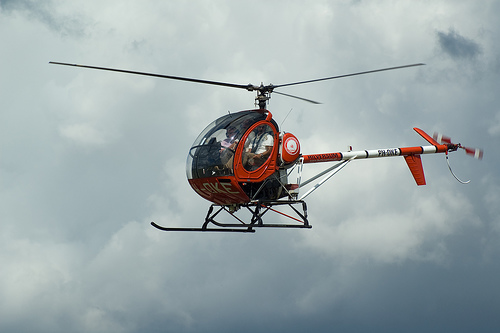<image>
Can you confirm if the cloud is in front of the chopper? No. The cloud is not in front of the chopper. The spatial positioning shows a different relationship between these objects. 